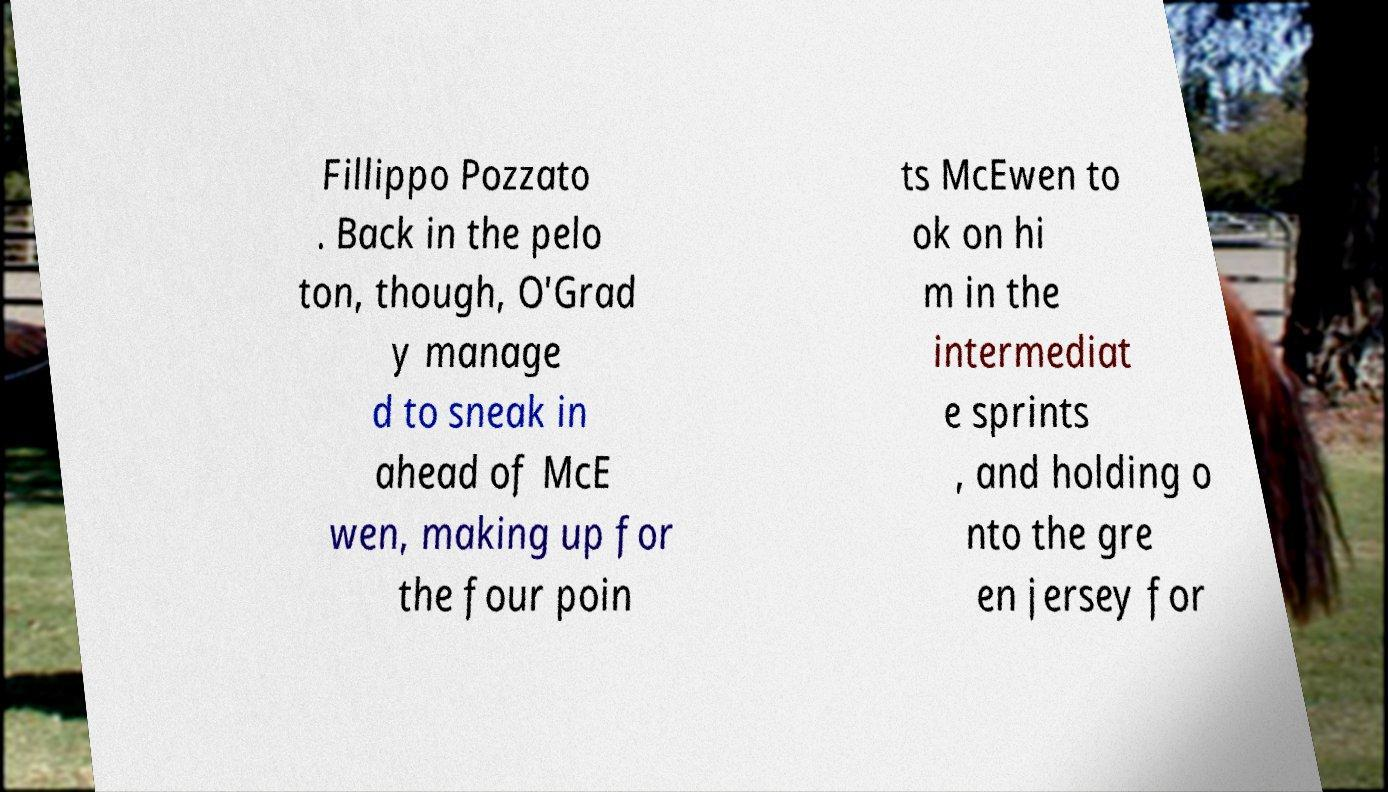There's text embedded in this image that I need extracted. Can you transcribe it verbatim? Fillippo Pozzato . Back in the pelo ton, though, O'Grad y manage d to sneak in ahead of McE wen, making up for the four poin ts McEwen to ok on hi m in the intermediat e sprints , and holding o nto the gre en jersey for 